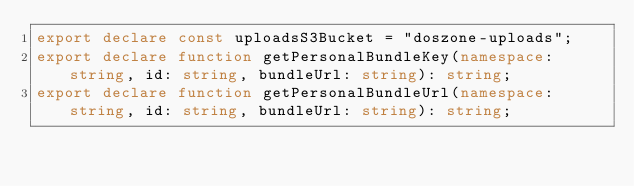Convert code to text. <code><loc_0><loc_0><loc_500><loc_500><_TypeScript_>export declare const uploadsS3Bucket = "doszone-uploads";
export declare function getPersonalBundleKey(namespace: string, id: string, bundleUrl: string): string;
export declare function getPersonalBundleUrl(namespace: string, id: string, bundleUrl: string): string;
</code> 